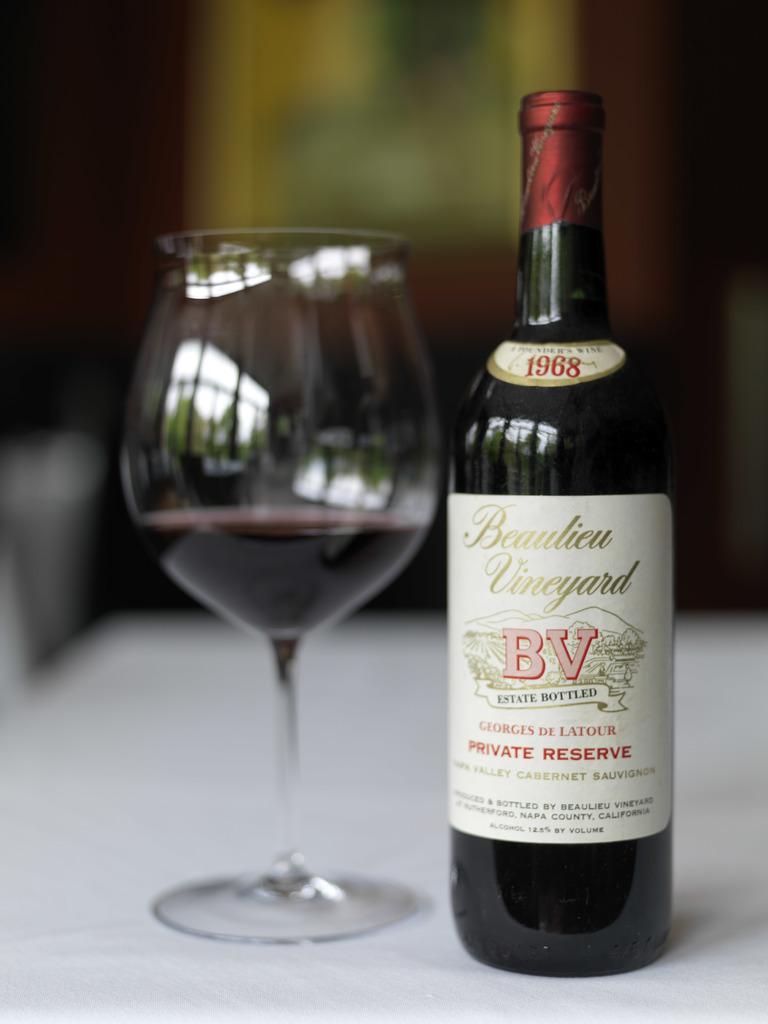Describe this image in one or two sentences. In this image in front there is a glass and a wine bottle on the table. In the background of the image there is a wall with the photo frame on it. 